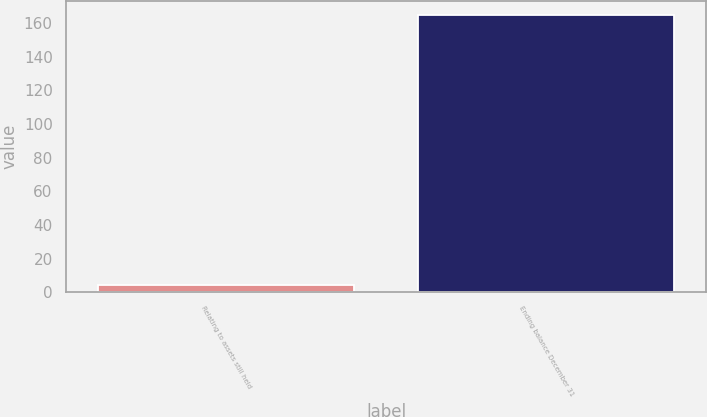<chart> <loc_0><loc_0><loc_500><loc_500><bar_chart><fcel>Relating to assets still held<fcel>Ending balance December 31<nl><fcel>4<fcel>165<nl></chart> 